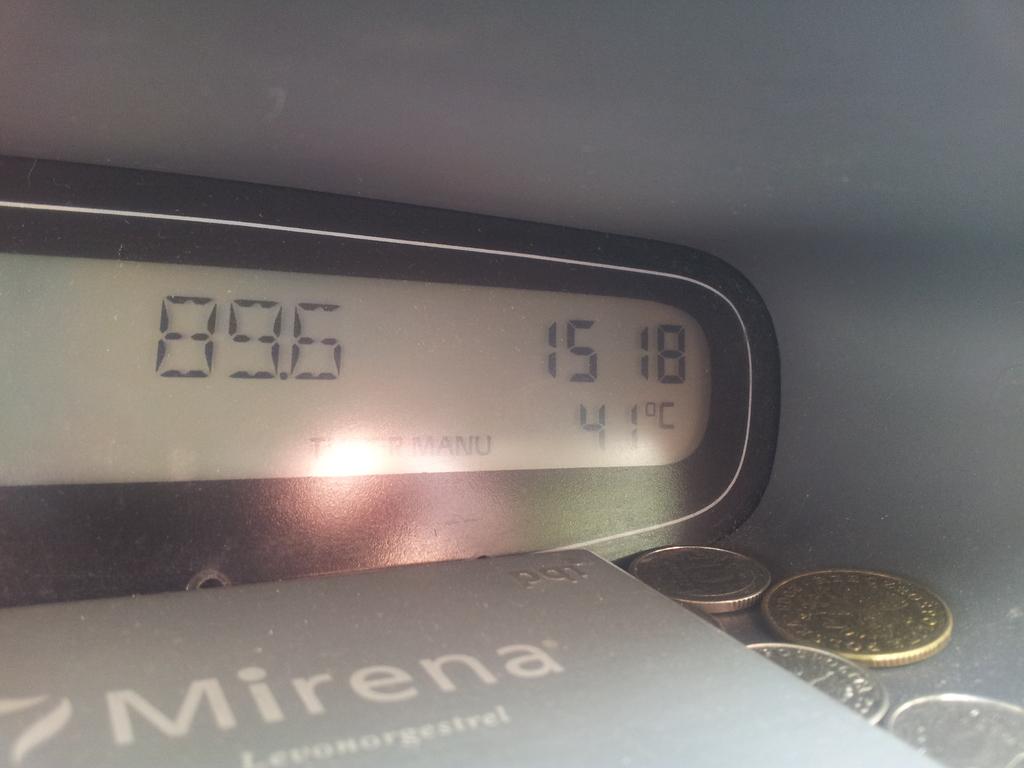What time is it?
Give a very brief answer. 15:18. How many coins are in the picture?
Keep it short and to the point. 4. 